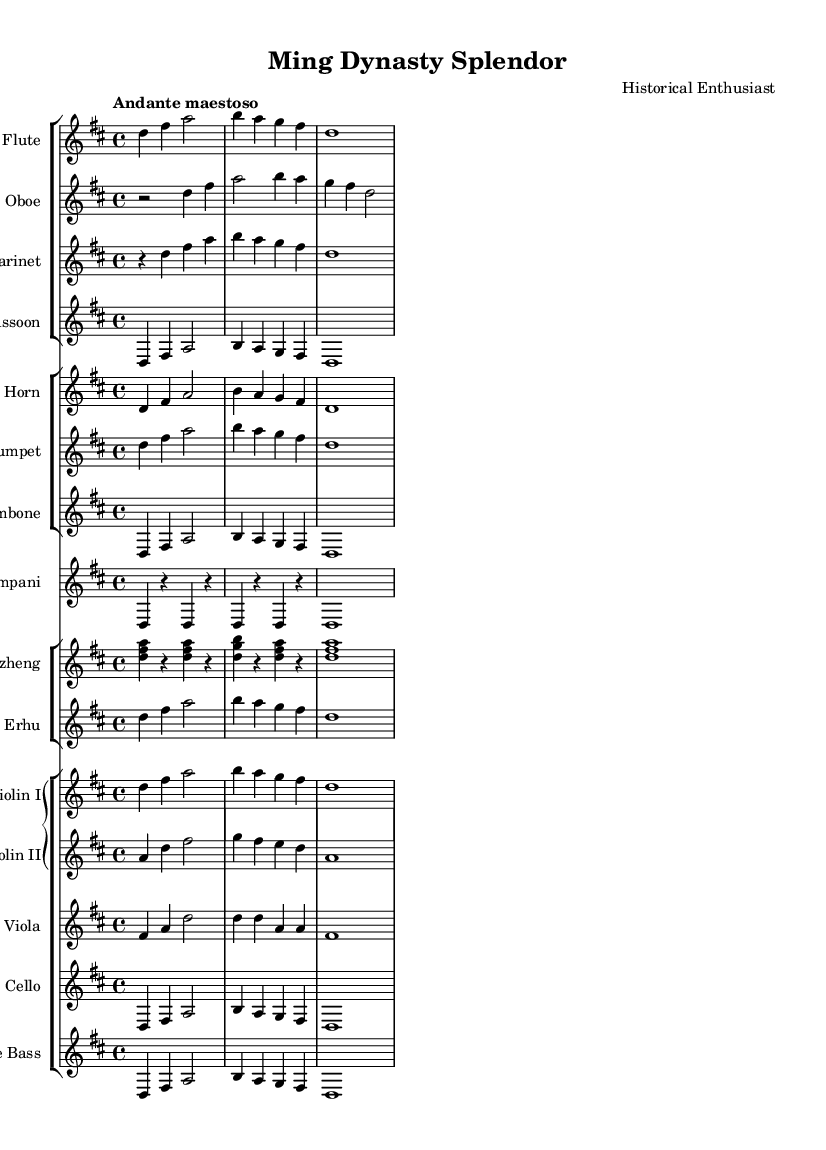What is the key signature of this music? The key signature is marked at the beginning of the score, showing two sharps, indicating D major.
Answer: D major What is the time signature of the piece? The time signature is indicated after the key signature, showing a 4/4 time signature, which means there are four beats in each measure.
Answer: 4/4 What is the tempo marking of the piece? The tempo marking is stated above the staff as "Andante maestoso," indicating a moderately slow and dignified pace.
Answer: Andante maestoso How many different sections of instruments are there in this symphony? By observing the score, there are four distinct sections: woodwinds, brass, percussion, and strings, indicating the orchestral arrangement.
Answer: Four Which instruments are featured in the woodwinds section? The woodwinds section includes flute, oboe, clarinet, and bassoon, as listed in the first staff grouping in the score.
Answer: Flute, oboe, clarinet, bassoon Which instrument provides the rhythmic foundation in this score? The timpani serves as the primary rhythmic foundation, marked in a separate staff, providing the pulse and accentuation of the piece.
Answer: Timpani What traditional instrument is included that represents the Ming Dynasty's cultural heritage? The guzheng is included in the orchestration, which is a traditional Chinese string instrument, reflecting the artistic achievements of the Ming era.
Answer: Guzheng 